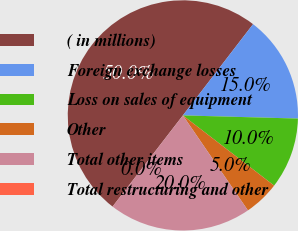Convert chart. <chart><loc_0><loc_0><loc_500><loc_500><pie_chart><fcel>( in millions)<fcel>Foreign exchange losses<fcel>Loss on sales of equipment<fcel>Other<fcel>Total other items<fcel>Total restructuring and other<nl><fcel>49.98%<fcel>15.0%<fcel>10.0%<fcel>5.01%<fcel>20.0%<fcel>0.01%<nl></chart> 